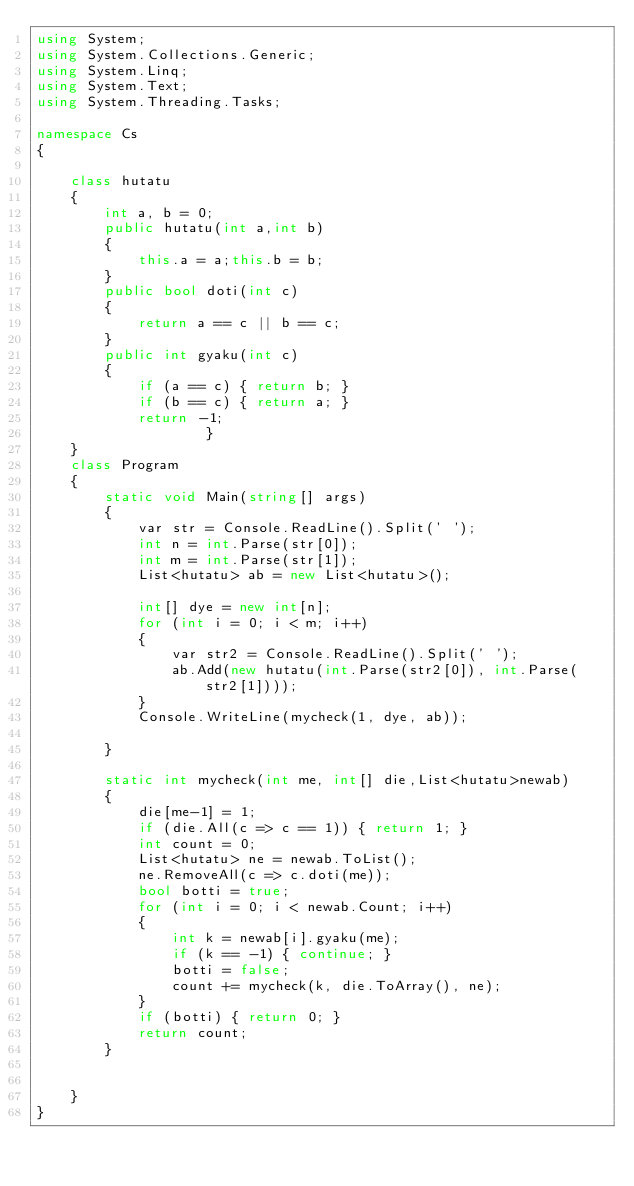<code> <loc_0><loc_0><loc_500><loc_500><_C#_>using System;
using System.Collections.Generic;
using System.Linq;
using System.Text;
using System.Threading.Tasks;

namespace Cs
{

    class hutatu
    {
        int a, b = 0;
        public hutatu(int a,int b)
        {
            this.a = a;this.b = b;
        }
        public bool doti(int c)
        {
            return a == c || b == c;
        }
        public int gyaku(int c)
        {
            if (a == c) { return b; }
            if (b == c) { return a; }
            return -1;
                    }
    }
    class Program
    {
        static void Main(string[] args)
        {
            var str = Console.ReadLine().Split(' ');
            int n = int.Parse(str[0]);
            int m = int.Parse(str[1]);
            List<hutatu> ab = new List<hutatu>();

            int[] dye = new int[n];
            for (int i = 0; i < m; i++)
            {
                var str2 = Console.ReadLine().Split(' ');
                ab.Add(new hutatu(int.Parse(str2[0]), int.Parse(str2[1])));
            }
            Console.WriteLine(mycheck(1, dye, ab));

        }

        static int mycheck(int me, int[] die,List<hutatu>newab)
        {
            die[me-1] = 1;
            if (die.All(c => c == 1)) { return 1; }
            int count = 0;
            List<hutatu> ne = newab.ToList();
            ne.RemoveAll(c => c.doti(me));
            bool botti = true;
            for (int i = 0; i < newab.Count; i++)
            {
                int k = newab[i].gyaku(me);
                if (k == -1) { continue; }
                botti = false;
                count += mycheck(k, die.ToArray(), ne);
            }
            if (botti) { return 0; }
            return count;
        }


    }
}
</code> 